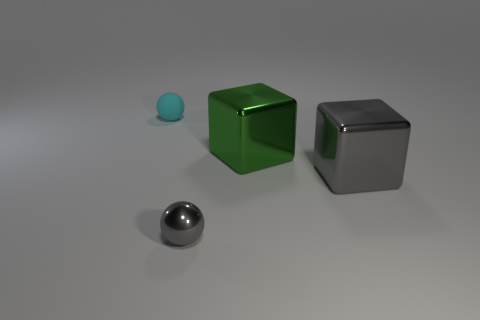Does the large gray object have the same material as the small cyan sphere?
Provide a short and direct response. No. How many things are tiny purple matte cubes or small cyan balls?
Offer a terse response. 1. How many green objects are made of the same material as the green block?
Ensure brevity in your answer.  0. There is a cyan matte object that is the same shape as the small gray metal thing; what size is it?
Provide a succinct answer. Small. Are there any balls in front of the small rubber ball?
Your answer should be very brief. Yes. What is the gray block made of?
Provide a succinct answer. Metal. Does the tiny sphere that is behind the tiny gray sphere have the same color as the shiny sphere?
Keep it short and to the point. No. Is there anything else that is the same shape as the matte thing?
Your response must be concise. Yes. The rubber object that is the same shape as the tiny metallic thing is what color?
Your response must be concise. Cyan. What is the small sphere that is to the left of the small gray ball made of?
Your answer should be very brief. Rubber. 